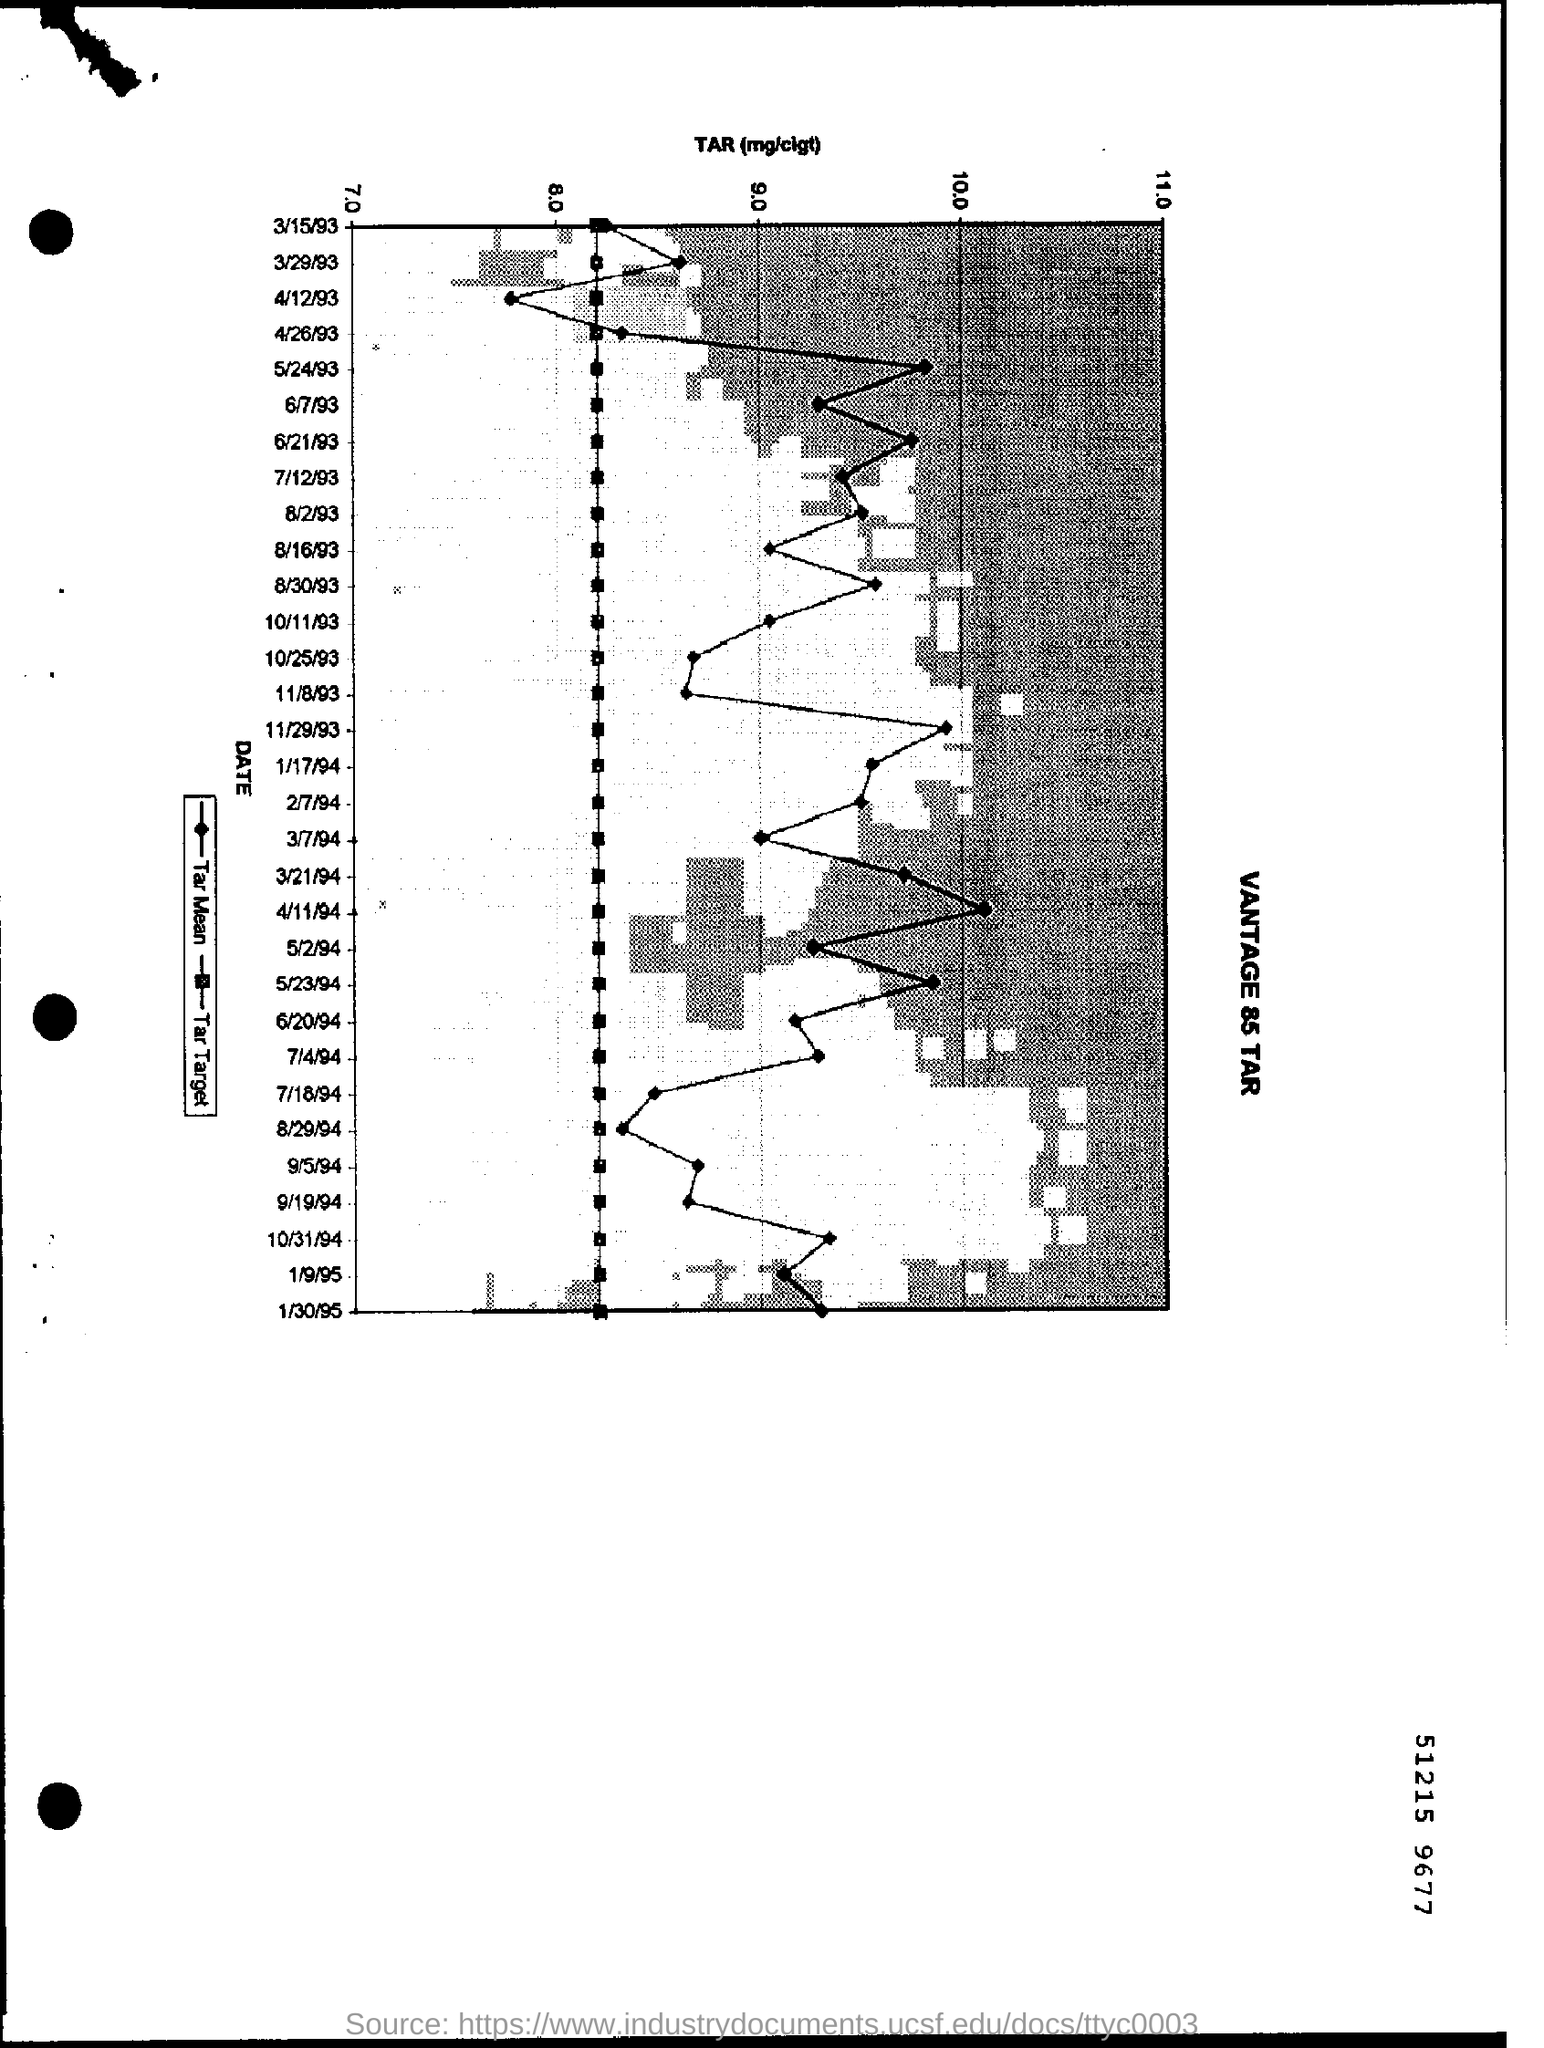Outline some significant characteristics in this image. The starting rate of TAR bar is 7.0 micrograms per liter per gram. On April 11, 1994, the highest TAR rate was shown in the graph. 